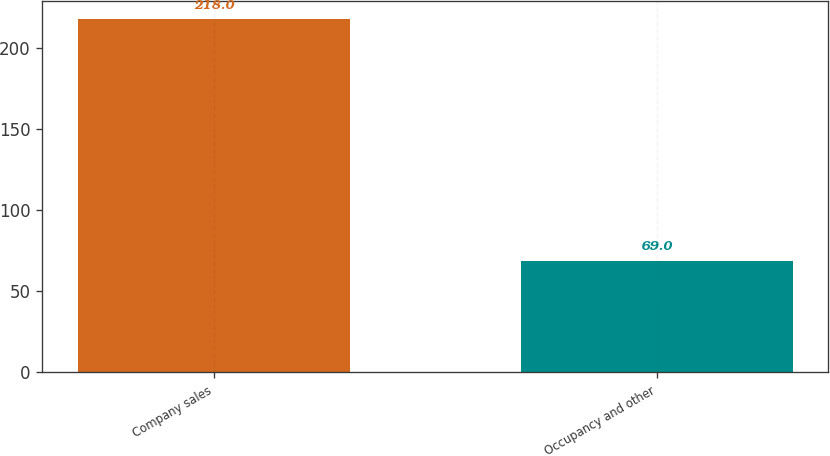Convert chart. <chart><loc_0><loc_0><loc_500><loc_500><bar_chart><fcel>Company sales<fcel>Occupancy and other<nl><fcel>218<fcel>69<nl></chart> 